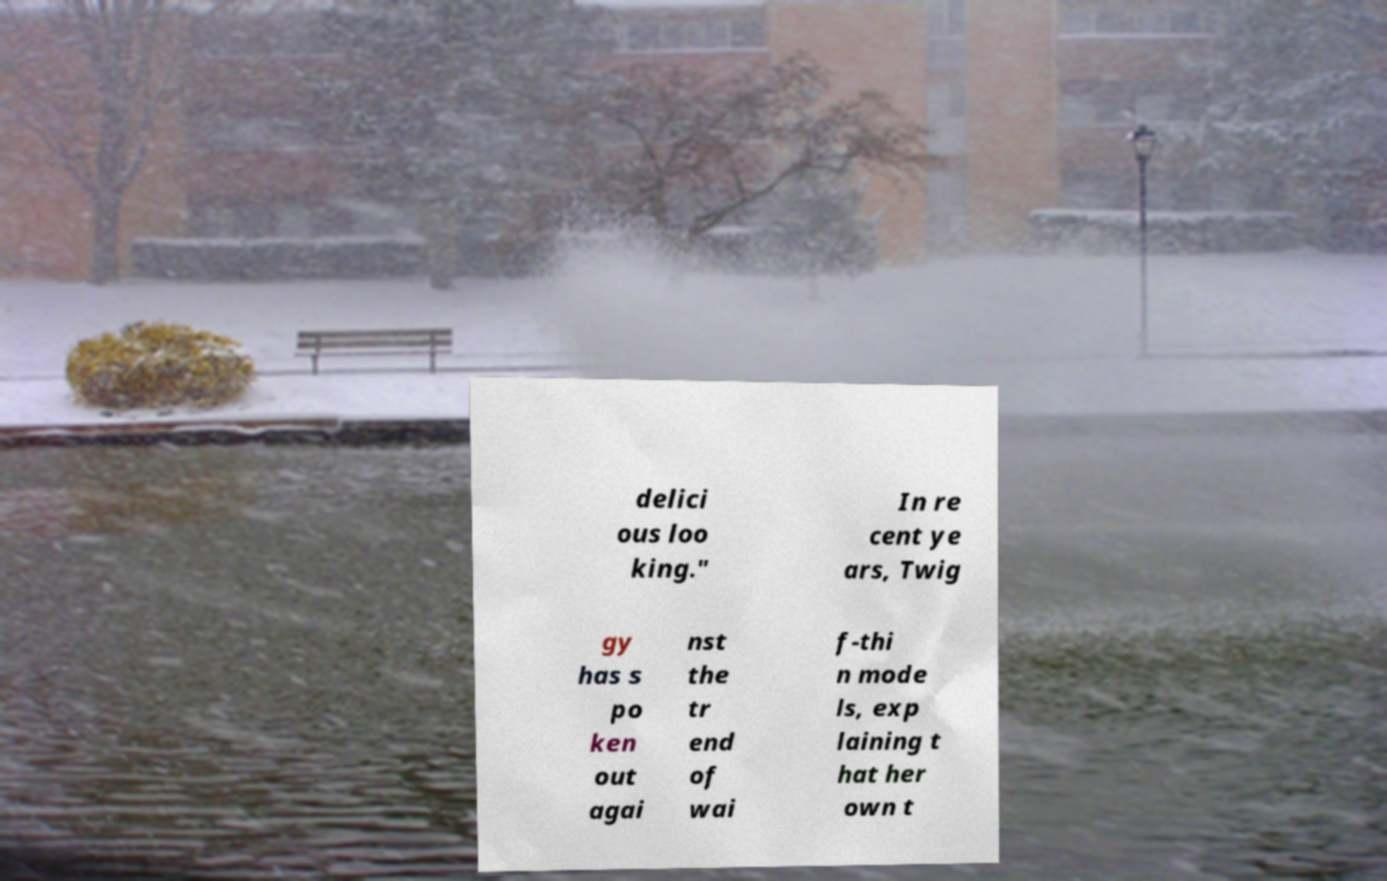For documentation purposes, I need the text within this image transcribed. Could you provide that? delici ous loo king." In re cent ye ars, Twig gy has s po ken out agai nst the tr end of wai f-thi n mode ls, exp laining t hat her own t 